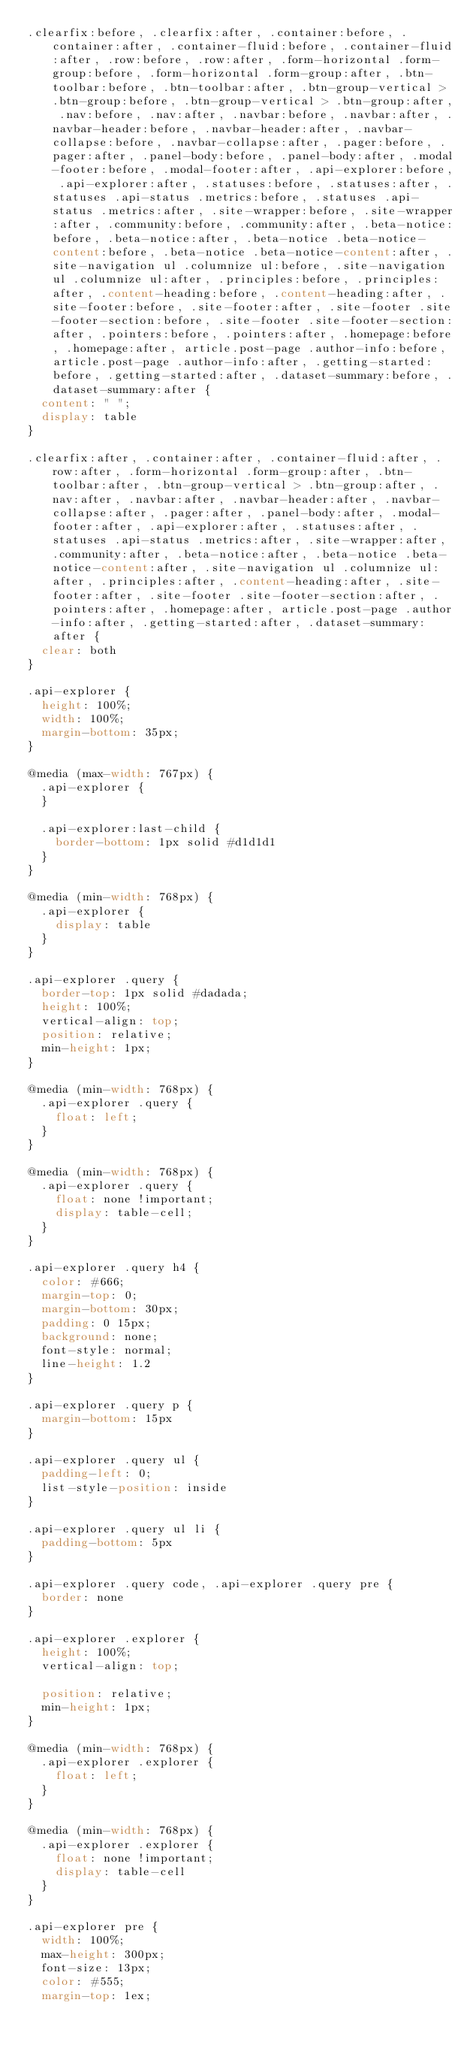<code> <loc_0><loc_0><loc_500><loc_500><_CSS_>.clearfix:before, .clearfix:after, .container:before, .container:after, .container-fluid:before, .container-fluid:after, .row:before, .row:after, .form-horizontal .form-group:before, .form-horizontal .form-group:after, .btn-toolbar:before, .btn-toolbar:after, .btn-group-vertical > .btn-group:before, .btn-group-vertical > .btn-group:after, .nav:before, .nav:after, .navbar:before, .navbar:after, .navbar-header:before, .navbar-header:after, .navbar-collapse:before, .navbar-collapse:after, .pager:before, .pager:after, .panel-body:before, .panel-body:after, .modal-footer:before, .modal-footer:after, .api-explorer:before, .api-explorer:after, .statuses:before, .statuses:after, .statuses .api-status .metrics:before, .statuses .api-status .metrics:after, .site-wrapper:before, .site-wrapper:after, .community:before, .community:after, .beta-notice:before, .beta-notice:after, .beta-notice .beta-notice-content:before, .beta-notice .beta-notice-content:after, .site-navigation ul .columnize ul:before, .site-navigation ul .columnize ul:after, .principles:before, .principles:after, .content-heading:before, .content-heading:after, .site-footer:before, .site-footer:after, .site-footer .site-footer-section:before, .site-footer .site-footer-section:after, .pointers:before, .pointers:after, .homepage:before, .homepage:after, article.post-page .author-info:before, article.post-page .author-info:after, .getting-started:before, .getting-started:after, .dataset-summary:before, .dataset-summary:after {
  content: " ";
  display: table
}

.clearfix:after, .container:after, .container-fluid:after, .row:after, .form-horizontal .form-group:after, .btn-toolbar:after, .btn-group-vertical > .btn-group:after, .nav:after, .navbar:after, .navbar-header:after, .navbar-collapse:after, .pager:after, .panel-body:after, .modal-footer:after, .api-explorer:after, .statuses:after, .statuses .api-status .metrics:after, .site-wrapper:after, .community:after, .beta-notice:after, .beta-notice .beta-notice-content:after, .site-navigation ul .columnize ul:after, .principles:after, .content-heading:after, .site-footer:after, .site-footer .site-footer-section:after, .pointers:after, .homepage:after, article.post-page .author-info:after, .getting-started:after, .dataset-summary:after {
  clear: both
}

.api-explorer {
  height: 100%;
  width: 100%;
  margin-bottom: 35px;
}

@media (max-width: 767px) {
  .api-explorer {
  }

  .api-explorer:last-child {
    border-bottom: 1px solid #d1d1d1
  }
}

@media (min-width: 768px) {
  .api-explorer {
    display: table
  }
}

.api-explorer .query {
  border-top: 1px solid #dadada;
  height: 100%;
  vertical-align: top;
  position: relative;
  min-height: 1px;
}

@media (min-width: 768px) {
  .api-explorer .query {
    float: left;
  }
}

@media (min-width: 768px) {
  .api-explorer .query {
    float: none !important;
    display: table-cell;
  }
}

.api-explorer .query h4 {
  color: #666;
  margin-top: 0;
  margin-bottom: 30px;
  padding: 0 15px;
  background: none;
  font-style: normal;
  line-height: 1.2
}

.api-explorer .query p {
  margin-bottom: 15px
}

.api-explorer .query ul {
  padding-left: 0;
  list-style-position: inside
}

.api-explorer .query ul li {
  padding-bottom: 5px
}

.api-explorer .query code, .api-explorer .query pre {
  border: none
}

.api-explorer .explorer {
  height: 100%;
  vertical-align: top;

  position: relative;
  min-height: 1px;
}

@media (min-width: 768px) {
  .api-explorer .explorer {
    float: left;
  }
}

@media (min-width: 768px) {
  .api-explorer .explorer {
    float: none !important;
    display: table-cell
  }
}

.api-explorer pre {
  width: 100%;
  max-height: 300px;
  font-size: 13px;
  color: #555;
  margin-top: 1ex;</code> 